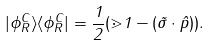Convert formula to latex. <formula><loc_0><loc_0><loc_500><loc_500>| \phi _ { R } ^ { C } \rangle \langle \phi _ { R } ^ { C } | = \frac { 1 } { 2 } ( \mathbb { m } { 1 } - ( \vec { \sigma } \cdot \hat { p } ) ) .</formula> 